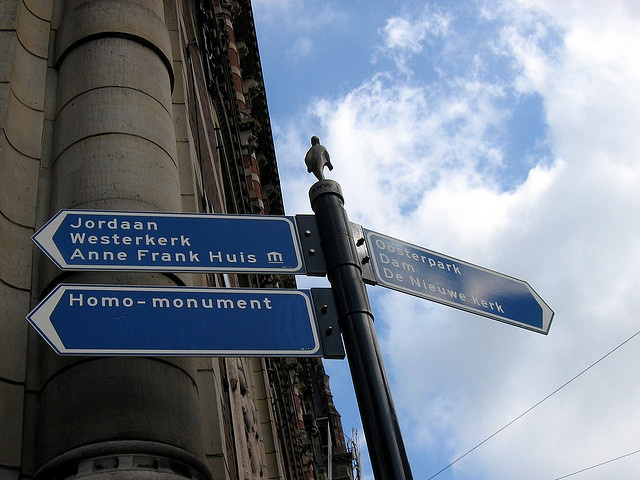Describe the objects in this image and their specific colors. I can see various objects in this image with different colors. 